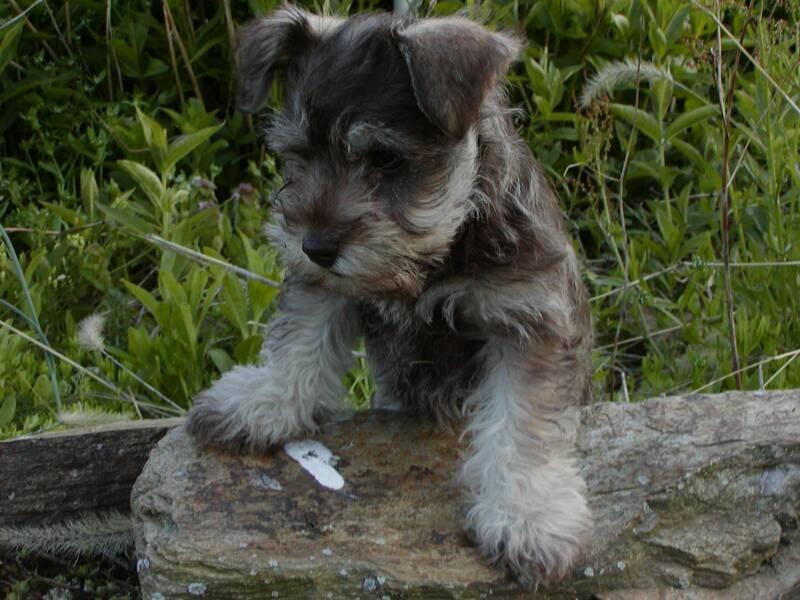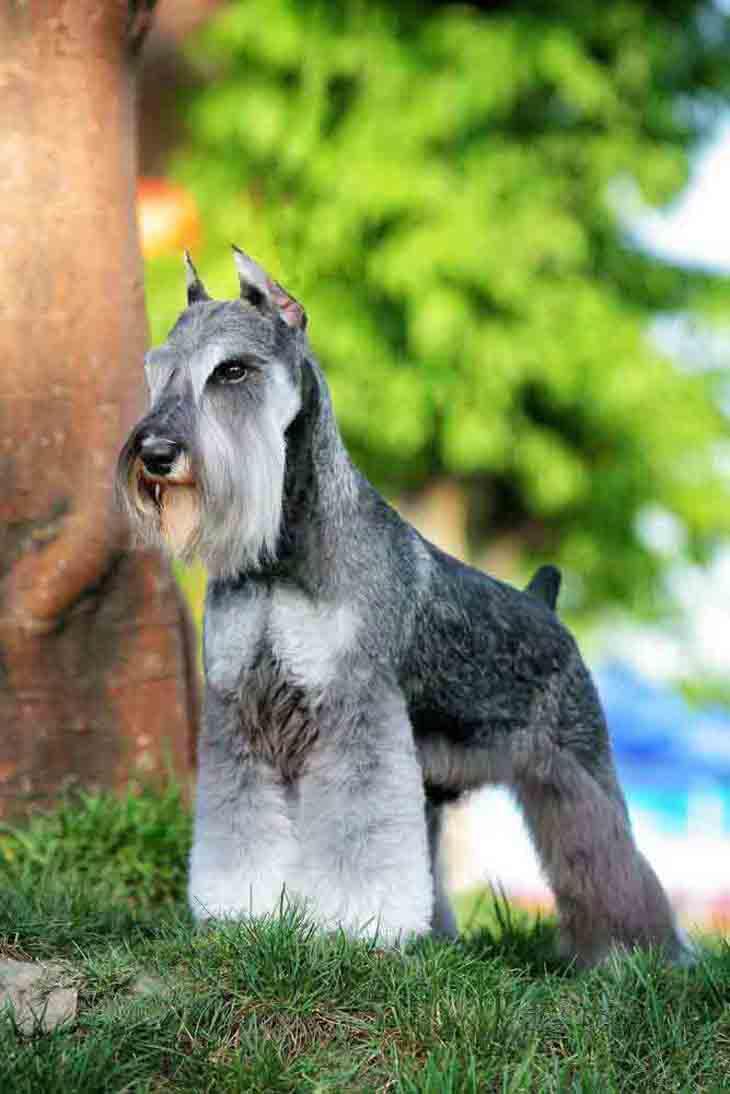The first image is the image on the left, the second image is the image on the right. Assess this claim about the two images: "There are three Schnauzers in one image, and one in the other.". Correct or not? Answer yes or no. No. The first image is the image on the left, the second image is the image on the right. Given the left and right images, does the statement "a dog is posing with a taught loop around it's neck" hold true? Answer yes or no. No. 